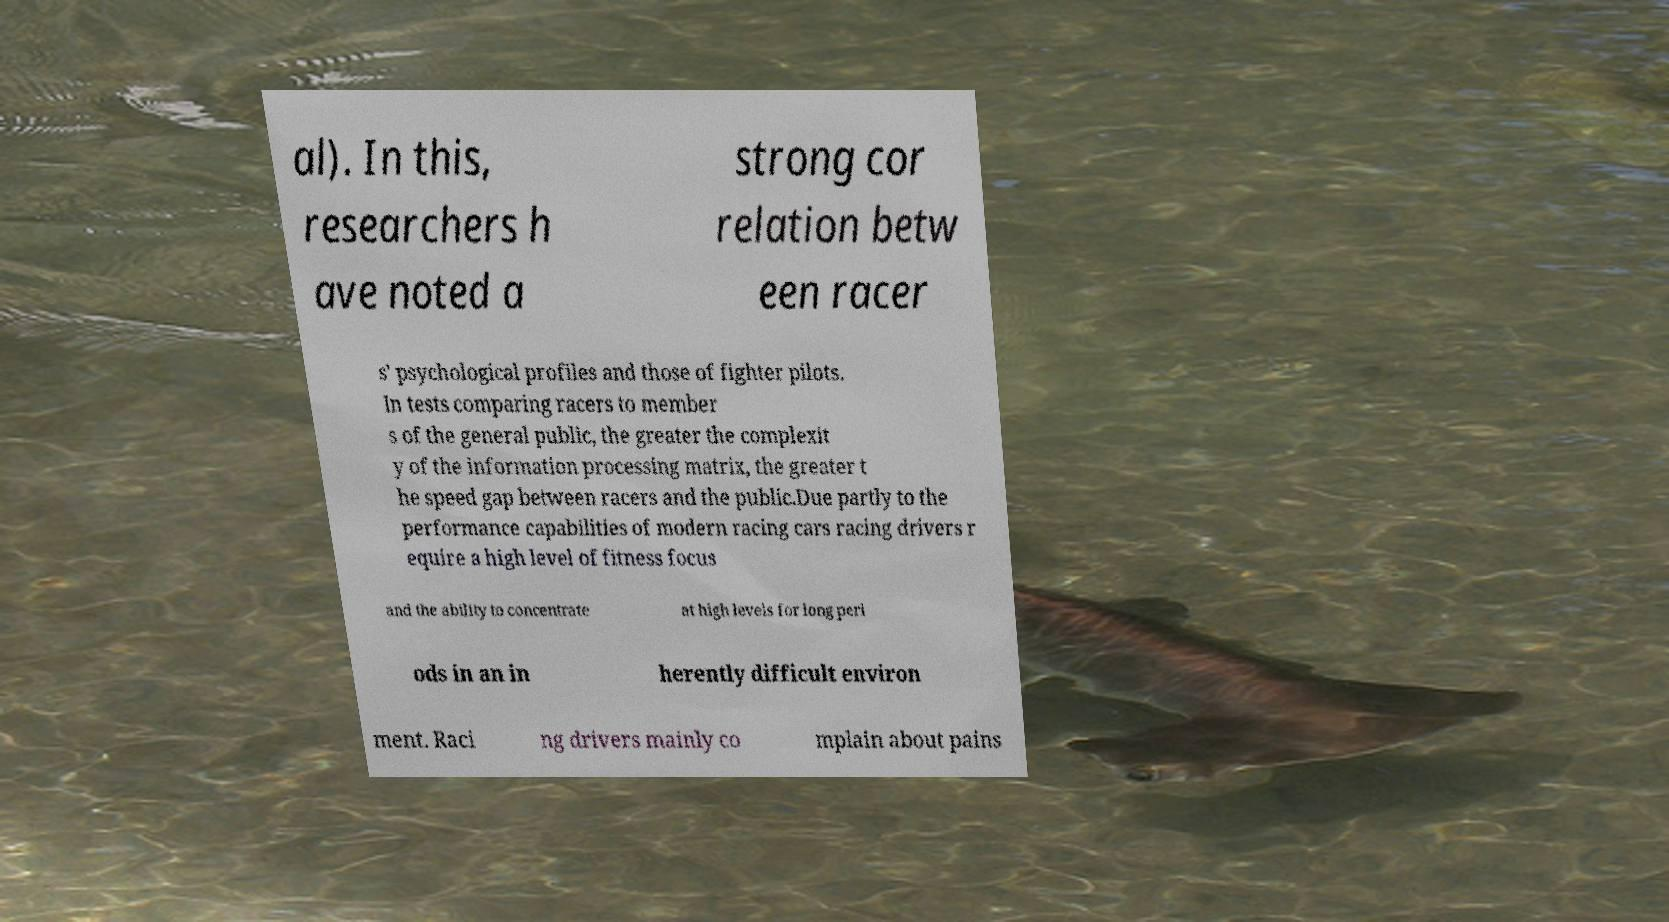What messages or text are displayed in this image? I need them in a readable, typed format. al). In this, researchers h ave noted a strong cor relation betw een racer s' psychological profiles and those of fighter pilots. In tests comparing racers to member s of the general public, the greater the complexit y of the information processing matrix, the greater t he speed gap between racers and the public.Due partly to the performance capabilities of modern racing cars racing drivers r equire a high level of fitness focus and the ability to concentrate at high levels for long peri ods in an in herently difficult environ ment. Raci ng drivers mainly co mplain about pains 